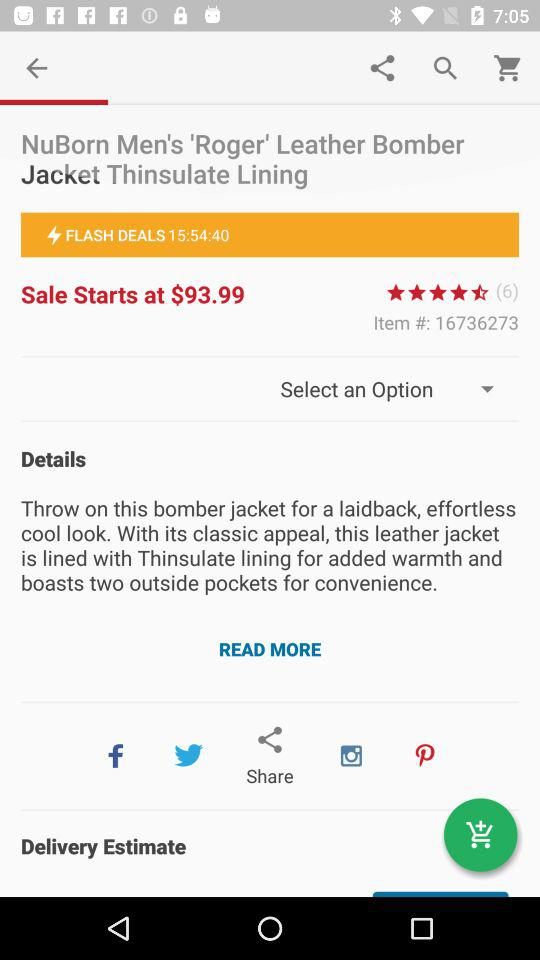What is the item number? The item number is 16736273. 